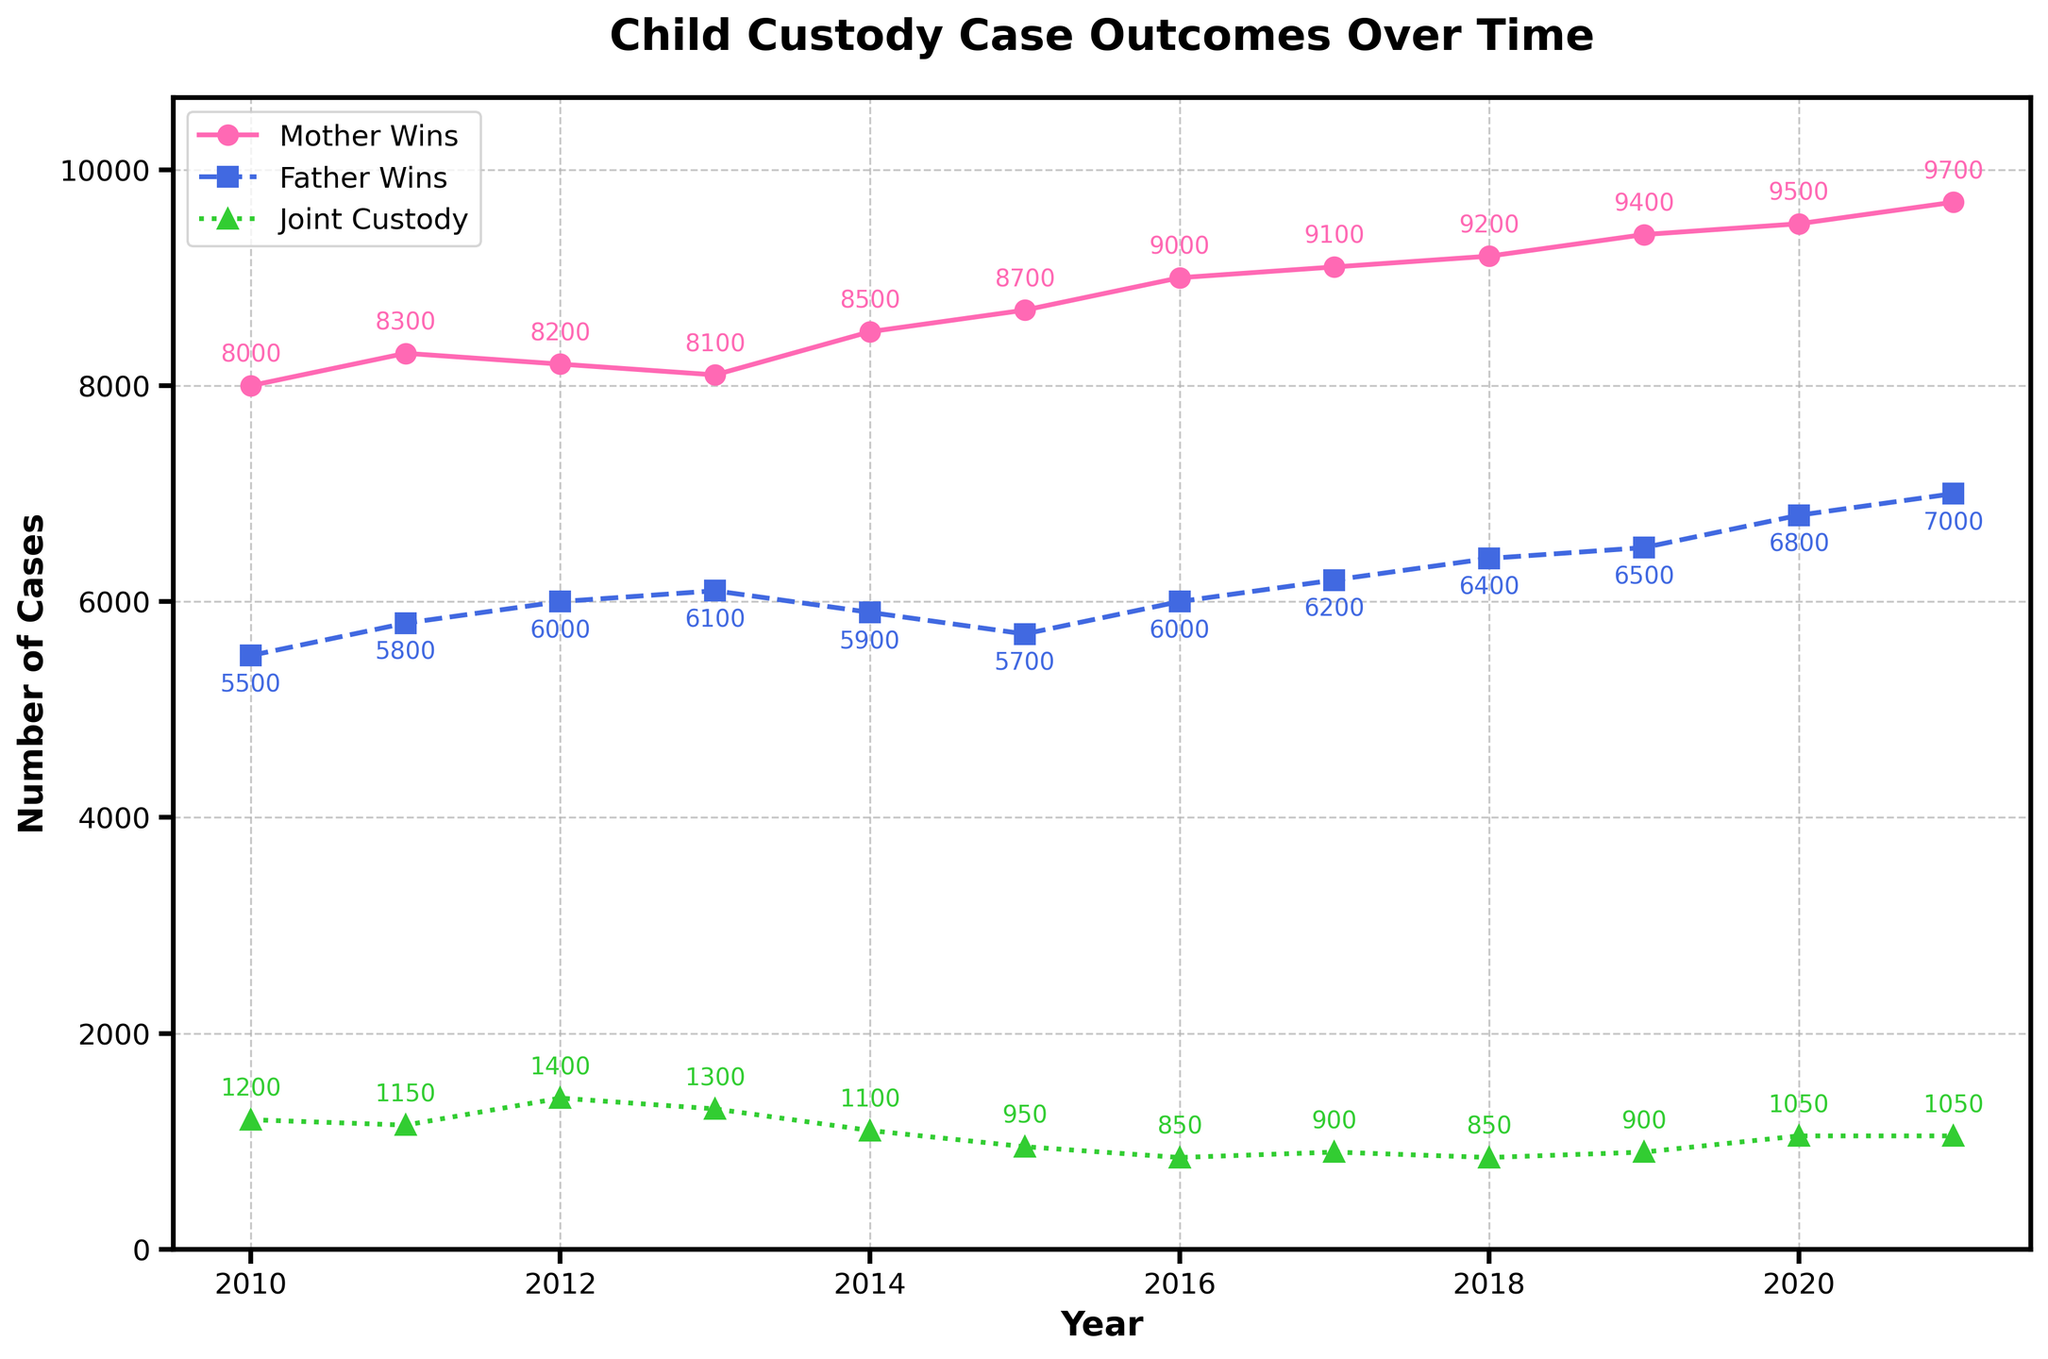What is the title of the plot? The title of the plot is located at the top and provides a summary of what the plot represents. In this case, it informs us about the subject of the data, which is child custody case outcomes over time.
Answer: Child Custody Case Outcomes Over Time How many custody outcomes are tracked over the years in the plot? The plot tracks three specific custody outcomes: Mother Wins, Father Wins, and Joint Custody. These are distinguishable by different lines and markers on the plot.
Answer: 3 What is the trend for Father Wins from 2010 to 2021? To spot the trend, look at the line corresponding to Father Wins (blue dashed line). Over the years, the line generally moves upward, illustrating an increasing trend.
Answer: Increasing Which year had the highest number of Mother Wins, and what was the value? Look for the peak value on the line representing Mother Wins (pink solid line). This highest point is in the year 2021 with a value of 9700.
Answer: 2021, 9700 Compare the number of Joint Custody cases in 2010 and 2021. Which year had more cases, and by how much? Check the values for Joint Custody (green dotted line) for the years 2010 and 2021. In 2010, there were 1200 cases, and in 2021, there were 1050 cases. Subtract the latter from the former: 1200 - 1050 = 150. Therefore, 2010 had 150 more cases.
Answer: 2010, 150 What was the difference in the number of Father Wins and Mother Wins in the year 2013? Look at the values for the year 2013: Mother Wins had 8100 and Father Wins had 6100. Subtract the Father Wins from Mother Wins: 8100 - 6100 = 2000.
Answer: 2000 In which years did the number of Father Wins surpass 6000? Look at the values on the Father Wins line (blue dashed line) for each year. The values surpass 6000 from 2012 onwards.
Answer: 2012 to 2021 What is the average number of cases for Joint Custody over the given years? Sum the Joint Custody values from 2010 to 2021 (1200 + 1150 + 1400 + 1300 + 1100 + 950 + 850 + 900 + 850 + 900 + 1050 + 1050) which equals 13500. Divide by the number of years (12): 13500 / 12 = 1125.
Answer: 1125 Which outcome has the least number of cases in 2015? Examine the values for Mother Wins (8700), Father Wins (5700), and Joint Custody (950) in 2015. The Joint Custody has the least number of cases.
Answer: Joint Custody 